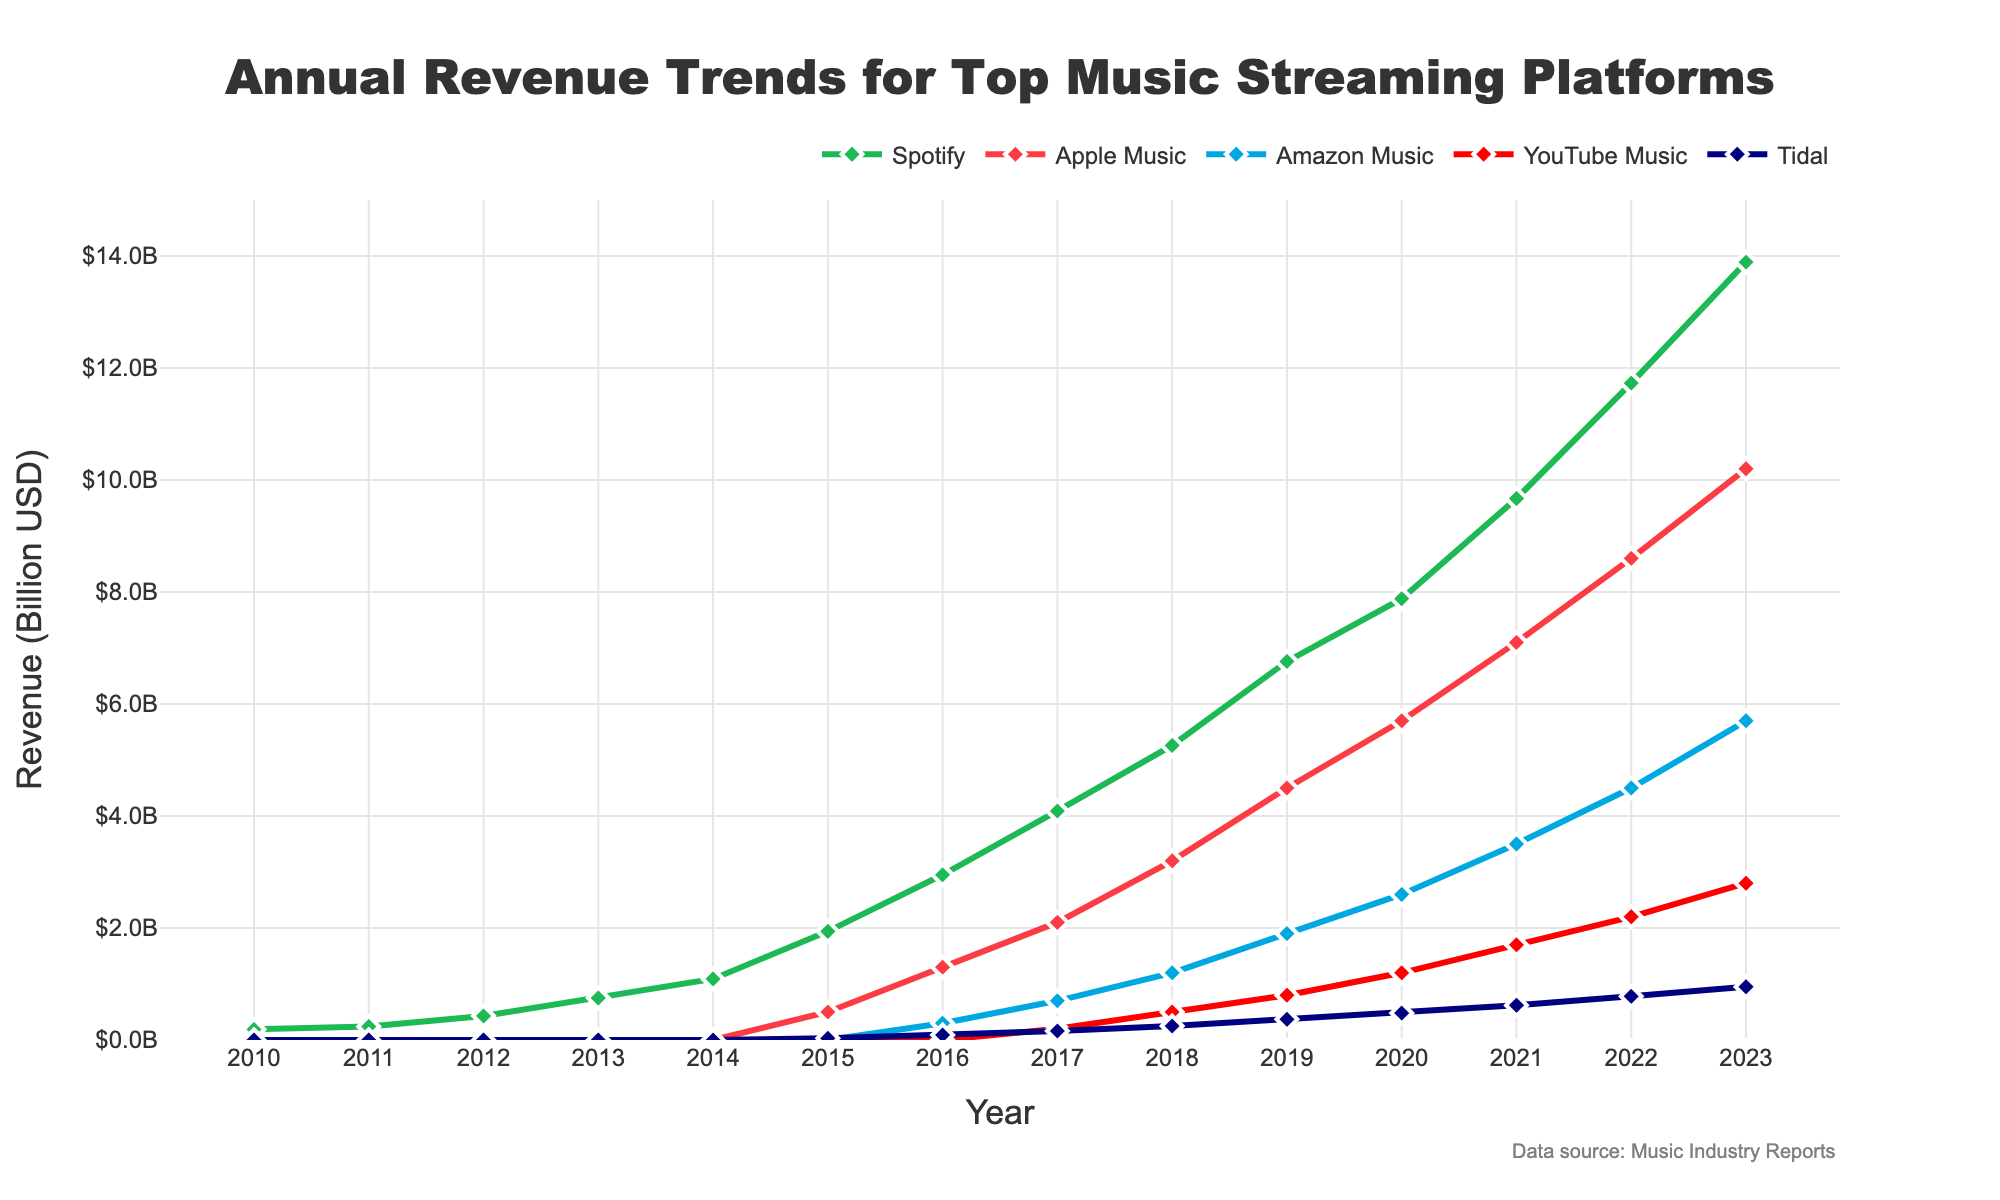What's the revenue trend for Spotify from 2010 to 2023? Look at the line representing Spotify from 2010 to 2023. It starts at 0.19 billion USD in 2010 and shows a generally increasing trend, reaching 13.89 billion USD in 2023.
Answer: Increasing Which streaming platform had the highest revenue in 2023? Check the endpoint of each line for 2023. The highest point corresponds to Spotify with 13.89 billion USD.
Answer: Spotify How does Amazon Music's revenue in 2023 compare to its revenue in 2015? Identify the plot points for Amazon Music in 2023 and 2015. In 2023, it is 5.7 billion USD and in 2015, it is 0 billion USD.
Answer: Higher in 2023 How much did Apple Music’s revenue increase from 2016 to 2023? Subtract the revenue in 2016 (1.3 billion USD) from the revenue in 2023 (10.2 billion USD). The increase is 10.2 - 1.3 = 8.9 billion USD.
Answer: 8.9 billion USD Which platform showed the most significant growth in revenue between 2015 and 2023? Calculate the difference between 2023 and 2015 for all platforms. Spotify (13.89 - 1.94 = 11.95), Apple Music (10.2 - 0.5 = 9.7), Amazon Music (5.7 - 0 = 5.7), YouTube Music (2.8 - 0 = 2.8), Tidal (0.95 - 0.03 = 0.92). The platform with the highest difference is Spotify.
Answer: Spotify What is the total revenue of all platforms combined in 2023? Sum the revenues of all platforms from the 2023 data points: 13.89 (Spotify) + 10.2 (Apple Music) + 5.7 (Amazon Music) + 2.8 (YouTube Music) + 0.95 (Tidal) = 33.54 billion USD.
Answer: 33.54 billion USD During which year did YouTube Music first report revenue, and how much was it? Look for the first non-zero revenue point for YouTube Music. In 2017, it reported 0.2 billion USD.
Answer: 2017, 0.2 billion USD How many years did it take for Apple Music to surpass a revenue of 5 billion USD? Starting from its launch in 2015, Apple Music surpassed 5 billion USD in 2020. So, it took 2020 - 2015 = 5 years.
Answer: 5 years Between Tidal and Amazon Music, which platform had a higher revenue in 2019? Compare the revenue points for Tidal and Amazon Music in 2019. Tidal has 0.37 billion USD, and Amazon Music has 1.9 billion USD. Amazon Music is higher.
Answer: Amazon Music From 2010 to 2013, what was the total revenue for Spotify? Sum the revenues of Spotify from 2010 to 2013: 0.19 (2010) + 0.24 (2011) + 0.43 (2012) + 0.75 (2013) = 1.61 billion USD.
Answer: 1.61 billion USD 